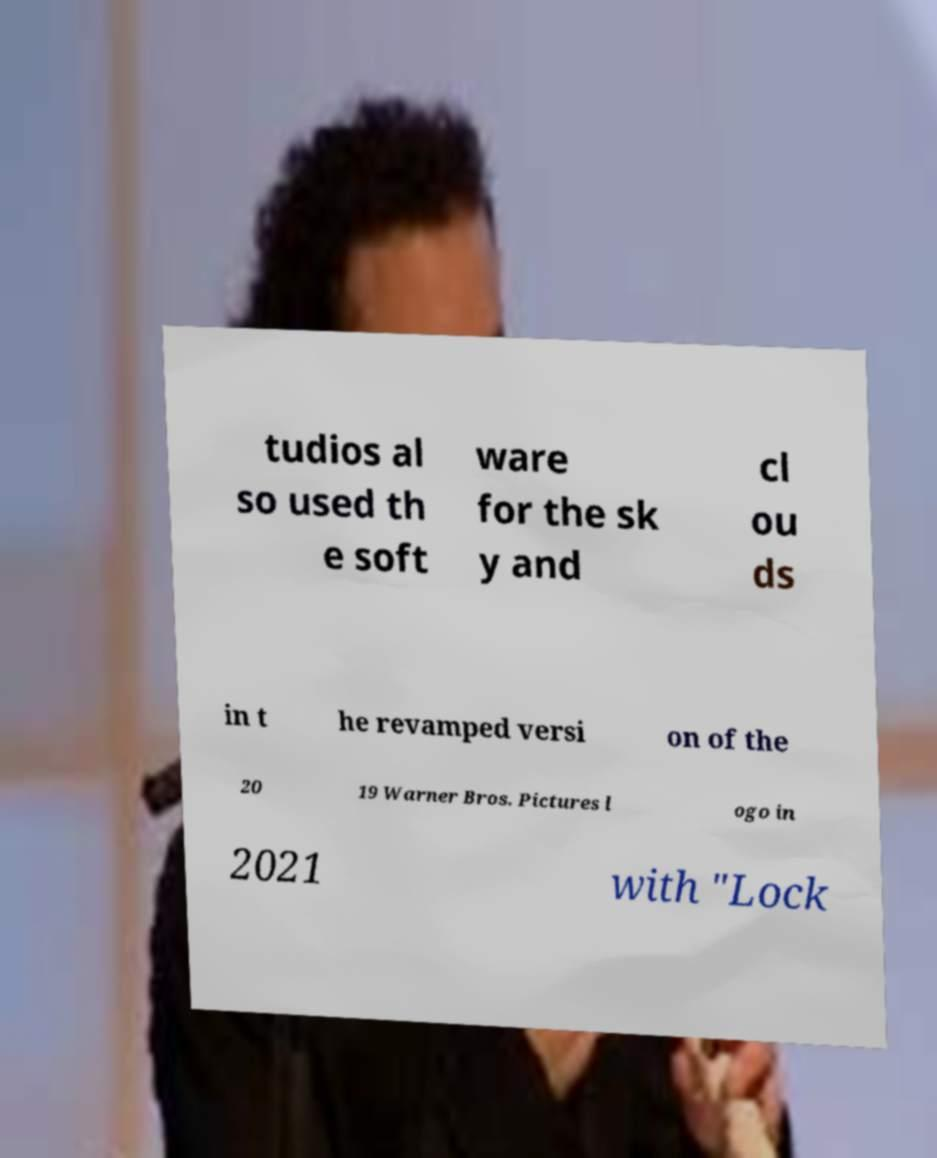There's text embedded in this image that I need extracted. Can you transcribe it verbatim? tudios al so used th e soft ware for the sk y and cl ou ds in t he revamped versi on of the 20 19 Warner Bros. Pictures l ogo in 2021 with "Lock 